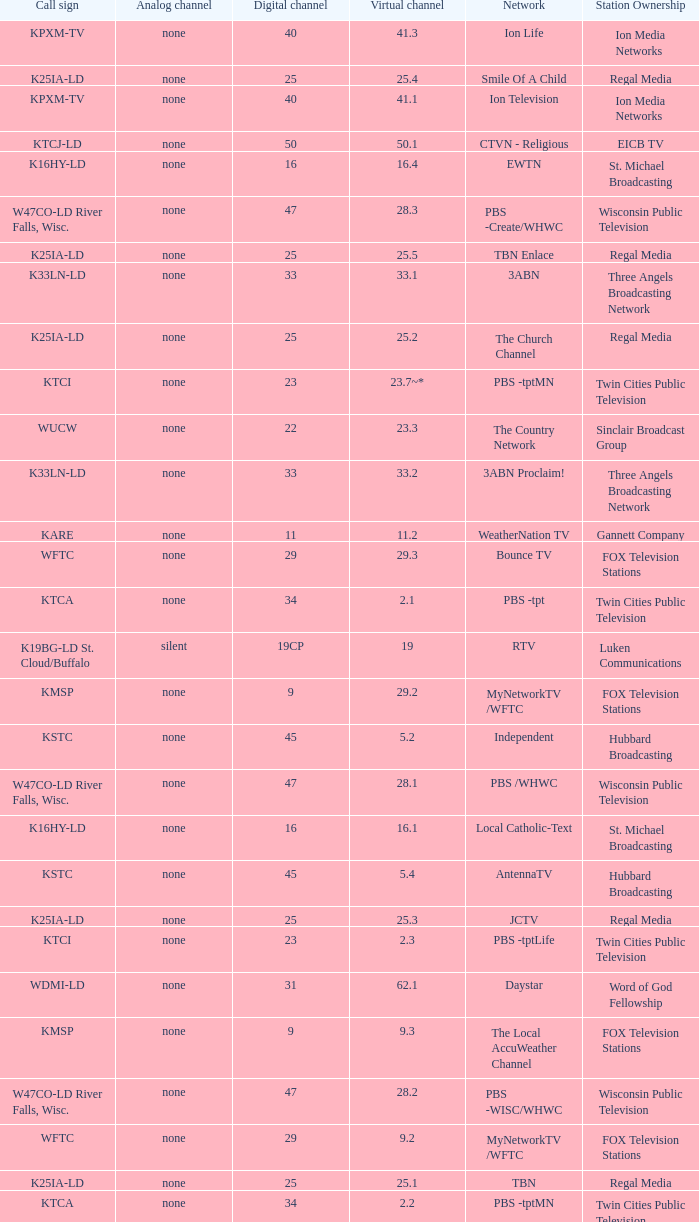Network of nbc is what digital channel? 11.0. 